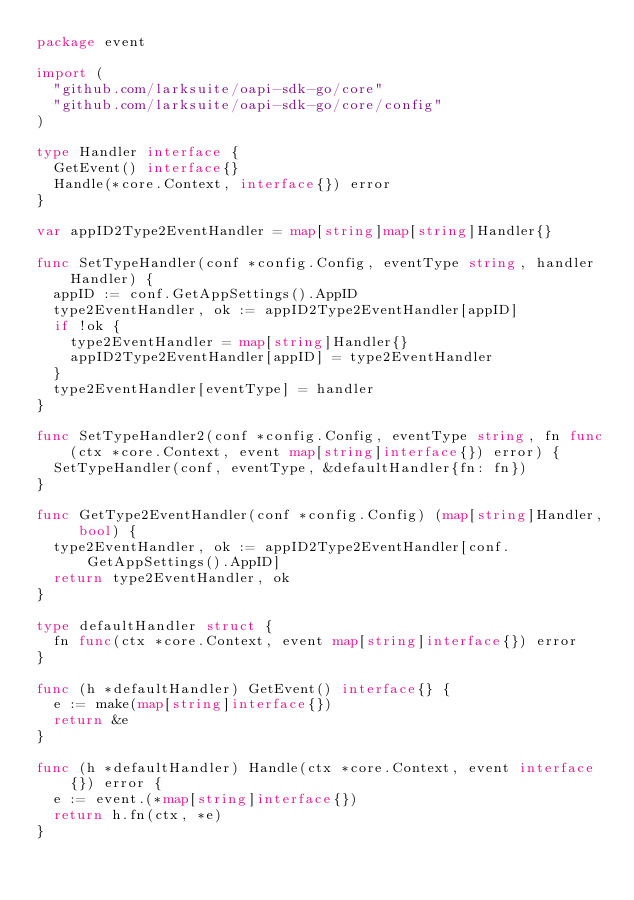Convert code to text. <code><loc_0><loc_0><loc_500><loc_500><_Go_>package event

import (
	"github.com/larksuite/oapi-sdk-go/core"
	"github.com/larksuite/oapi-sdk-go/core/config"
)

type Handler interface {
	GetEvent() interface{}
	Handle(*core.Context, interface{}) error
}

var appID2Type2EventHandler = map[string]map[string]Handler{}

func SetTypeHandler(conf *config.Config, eventType string, handler Handler) {
	appID := conf.GetAppSettings().AppID
	type2EventHandler, ok := appID2Type2EventHandler[appID]
	if !ok {
		type2EventHandler = map[string]Handler{}
		appID2Type2EventHandler[appID] = type2EventHandler
	}
	type2EventHandler[eventType] = handler
}

func SetTypeHandler2(conf *config.Config, eventType string, fn func(ctx *core.Context, event map[string]interface{}) error) {
	SetTypeHandler(conf, eventType, &defaultHandler{fn: fn})
}

func GetType2EventHandler(conf *config.Config) (map[string]Handler, bool) {
	type2EventHandler, ok := appID2Type2EventHandler[conf.GetAppSettings().AppID]
	return type2EventHandler, ok
}

type defaultHandler struct {
	fn func(ctx *core.Context, event map[string]interface{}) error
}

func (h *defaultHandler) GetEvent() interface{} {
	e := make(map[string]interface{})
	return &e
}

func (h *defaultHandler) Handle(ctx *core.Context, event interface{}) error {
	e := event.(*map[string]interface{})
	return h.fn(ctx, *e)
}
</code> 